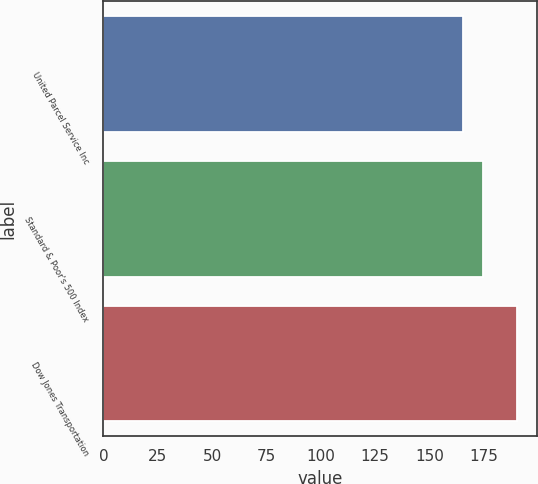Convert chart. <chart><loc_0><loc_0><loc_500><loc_500><bar_chart><fcel>United Parcel Service Inc<fcel>Standard & Poor's 500 Index<fcel>Dow Jones Transportation<nl><fcel>165.35<fcel>174.54<fcel>190.07<nl></chart> 